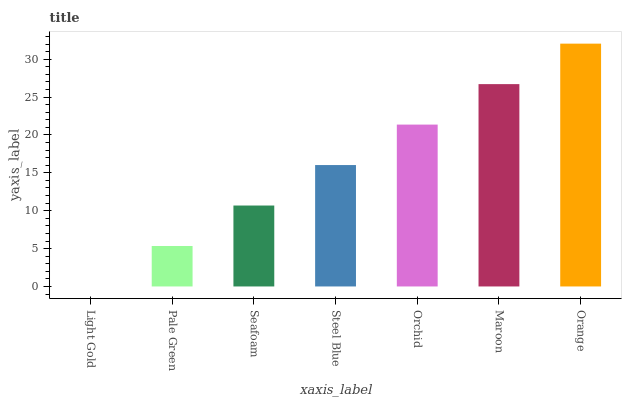Is Light Gold the minimum?
Answer yes or no. Yes. Is Orange the maximum?
Answer yes or no. Yes. Is Pale Green the minimum?
Answer yes or no. No. Is Pale Green the maximum?
Answer yes or no. No. Is Pale Green greater than Light Gold?
Answer yes or no. Yes. Is Light Gold less than Pale Green?
Answer yes or no. Yes. Is Light Gold greater than Pale Green?
Answer yes or no. No. Is Pale Green less than Light Gold?
Answer yes or no. No. Is Steel Blue the high median?
Answer yes or no. Yes. Is Steel Blue the low median?
Answer yes or no. Yes. Is Orange the high median?
Answer yes or no. No. Is Orange the low median?
Answer yes or no. No. 